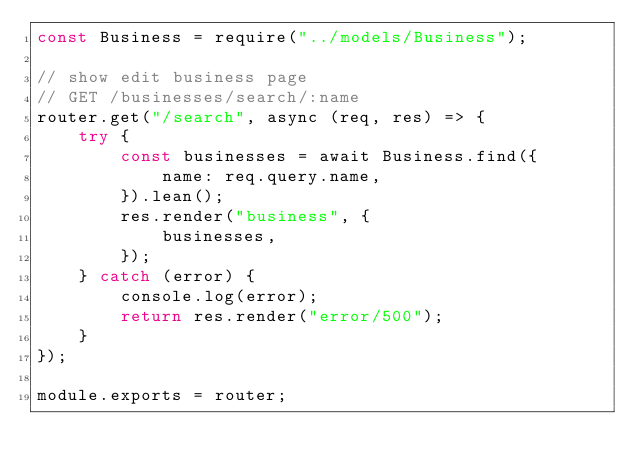<code> <loc_0><loc_0><loc_500><loc_500><_JavaScript_>const Business = require("../models/Business");

// show edit business page
// GET /businesses/search/:name
router.get("/search", async (req, res) => {
	try {
		const businesses = await Business.find({
			name: req.query.name,
		}).lean();
		res.render("business", {
			businesses,
		});
	} catch (error) {
		console.log(error);
		return res.render("error/500");
	}
});

module.exports = router;
</code> 